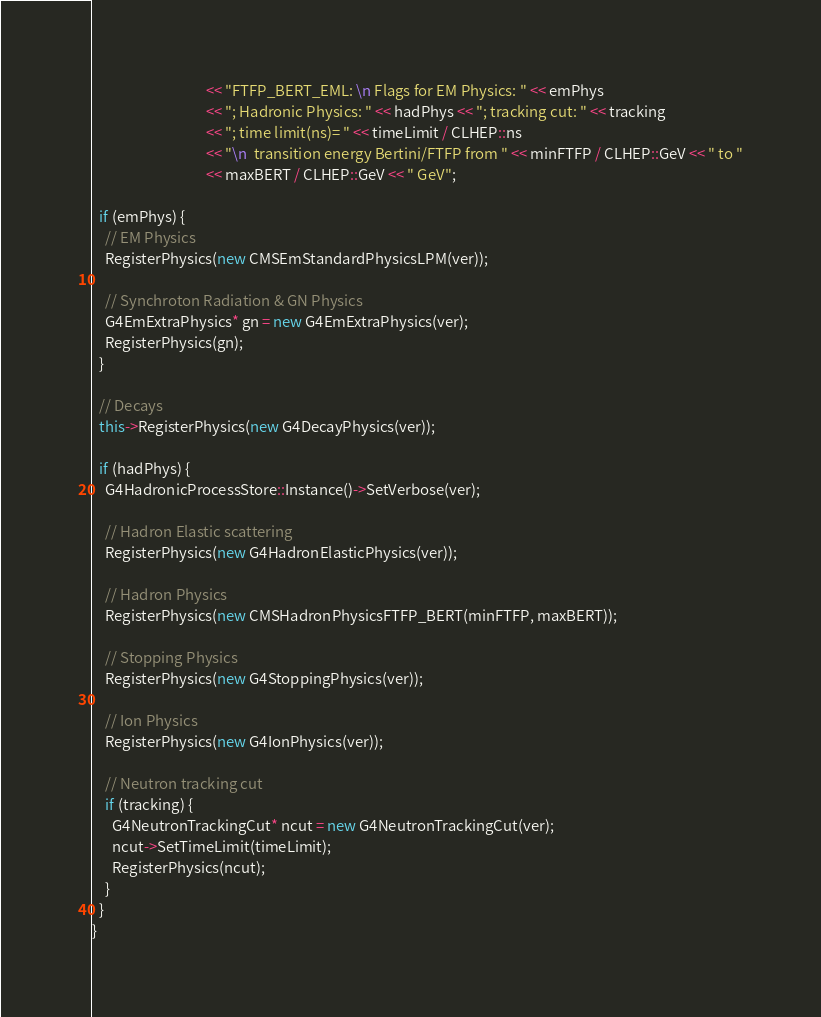<code> <loc_0><loc_0><loc_500><loc_500><_C++_>                                  << "FTFP_BERT_EML: \n Flags for EM Physics: " << emPhys
                                  << "; Hadronic Physics: " << hadPhys << "; tracking cut: " << tracking
                                  << "; time limit(ns)= " << timeLimit / CLHEP::ns
                                  << "\n  transition energy Bertini/FTFP from " << minFTFP / CLHEP::GeV << " to "
                                  << maxBERT / CLHEP::GeV << " GeV";

  if (emPhys) {
    // EM Physics
    RegisterPhysics(new CMSEmStandardPhysicsLPM(ver));

    // Synchroton Radiation & GN Physics
    G4EmExtraPhysics* gn = new G4EmExtraPhysics(ver);
    RegisterPhysics(gn);
  }

  // Decays
  this->RegisterPhysics(new G4DecayPhysics(ver));

  if (hadPhys) {
    G4HadronicProcessStore::Instance()->SetVerbose(ver);

    // Hadron Elastic scattering
    RegisterPhysics(new G4HadronElasticPhysics(ver));

    // Hadron Physics
    RegisterPhysics(new CMSHadronPhysicsFTFP_BERT(minFTFP, maxBERT));

    // Stopping Physics
    RegisterPhysics(new G4StoppingPhysics(ver));

    // Ion Physics
    RegisterPhysics(new G4IonPhysics(ver));

    // Neutron tracking cut
    if (tracking) {
      G4NeutronTrackingCut* ncut = new G4NeutronTrackingCut(ver);
      ncut->SetTimeLimit(timeLimit);
      RegisterPhysics(ncut);
    }
  }
}
</code> 